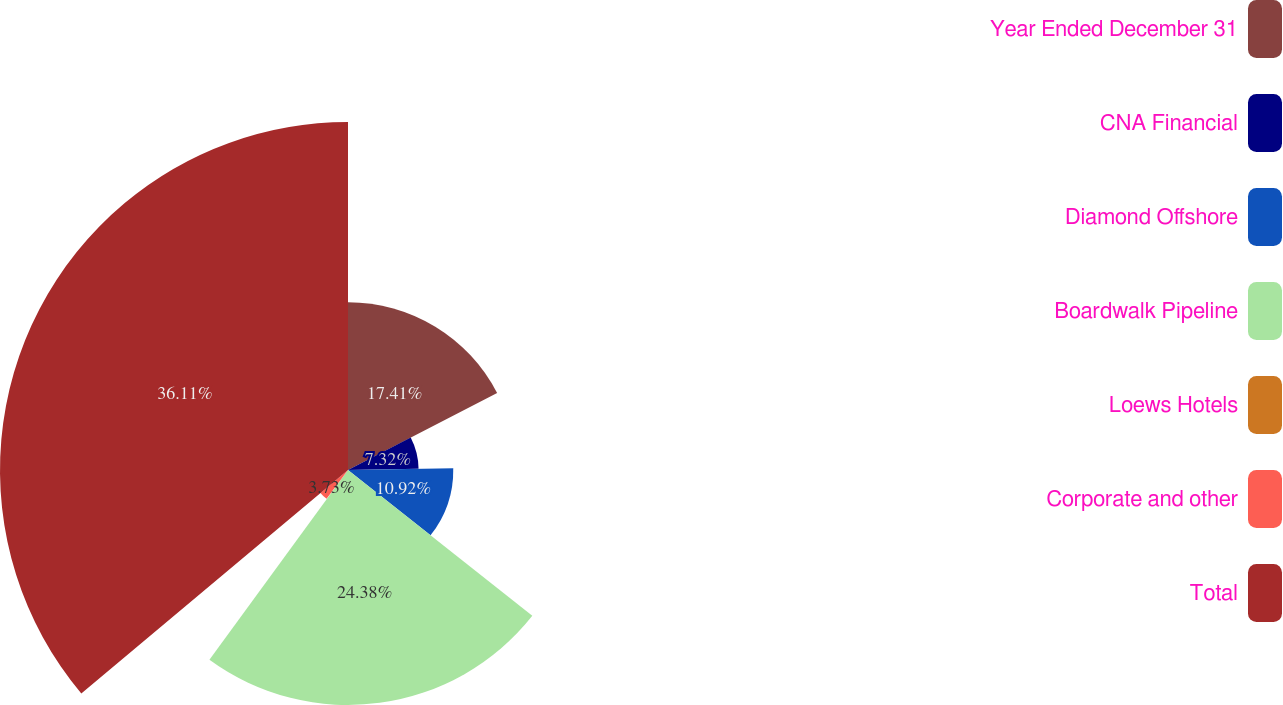Convert chart. <chart><loc_0><loc_0><loc_500><loc_500><pie_chart><fcel>Year Ended December 31<fcel>CNA Financial<fcel>Diamond Offshore<fcel>Boardwalk Pipeline<fcel>Loews Hotels<fcel>Corporate and other<fcel>Total<nl><fcel>17.41%<fcel>7.32%<fcel>10.92%<fcel>24.38%<fcel>0.13%<fcel>3.73%<fcel>36.1%<nl></chart> 